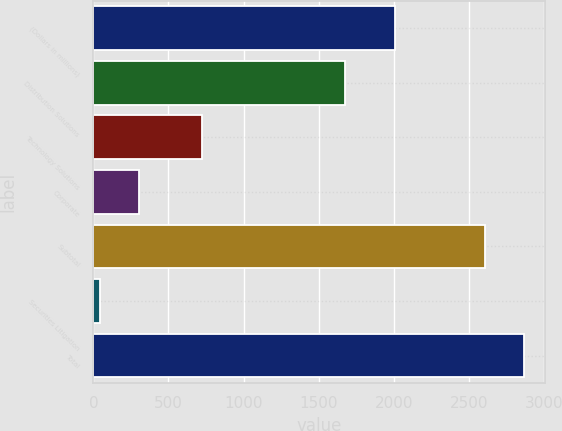Convert chart. <chart><loc_0><loc_0><loc_500><loc_500><bar_chart><fcel>(Dollars in millions)<fcel>Distribution Solutions<fcel>Technology Solutions<fcel>Corporate<fcel>Subtotal<fcel>Securities Litigation<fcel>Total<nl><fcel>2006<fcel>1673<fcel>720<fcel>305.6<fcel>2606<fcel>45<fcel>2866.6<nl></chart> 